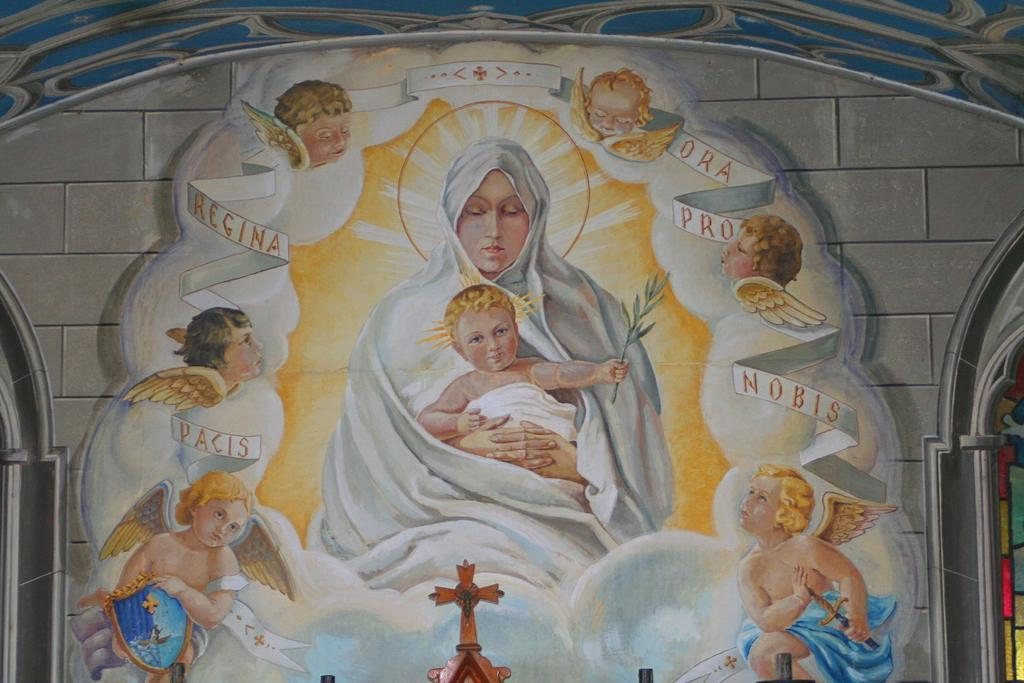What is on the wall in the image? There is a painting on the wall in the image. What is the subject matter of the painting? The painting depicts a woman holding a child. What type of quill is the woman using to write in the painting? There is no quill present in the painting; it depicts a woman holding a child. How many horses are visible in the painting? There are no horses visible in the painting; it depicts a woman holding a child. 